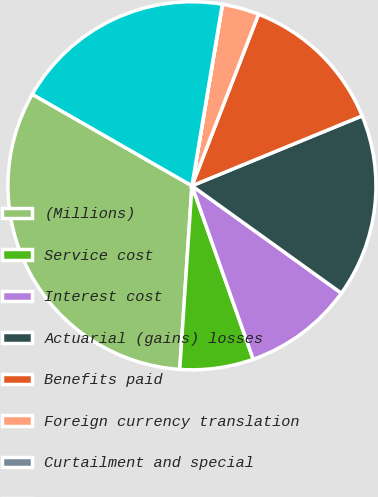Convert chart to OTSL. <chart><loc_0><loc_0><loc_500><loc_500><pie_chart><fcel>(Millions)<fcel>Service cost<fcel>Interest cost<fcel>Actuarial (gains) losses<fcel>Benefits paid<fcel>Foreign currency translation<fcel>Curtailment and special<fcel>Accounts payable and accrued<nl><fcel>32.23%<fcel>6.46%<fcel>9.68%<fcel>16.12%<fcel>12.9%<fcel>3.24%<fcel>0.02%<fcel>19.35%<nl></chart> 